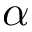Convert formula to latex. <formula><loc_0><loc_0><loc_500><loc_500>\alpha</formula> 